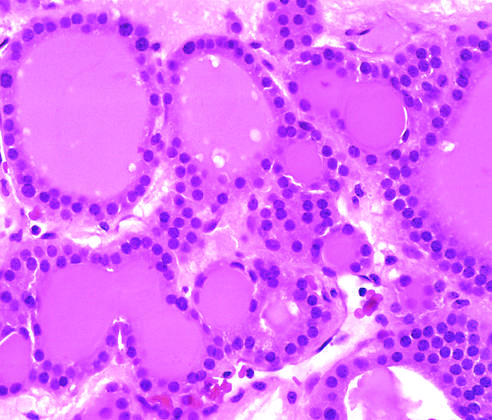how is a solitary, well-circumscribed nodule in this gross specimen?
Answer the question using a single word or phrase. Visible 